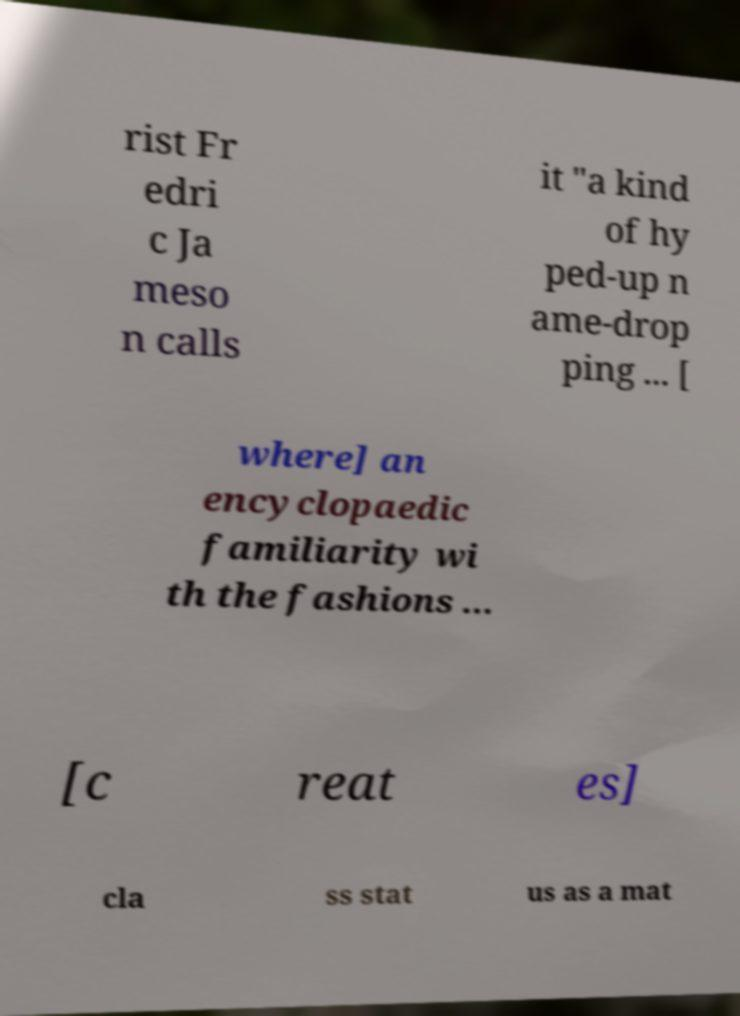Can you accurately transcribe the text from the provided image for me? rist Fr edri c Ja meso n calls it "a kind of hy ped-up n ame-drop ping ... [ where] an encyclopaedic familiarity wi th the fashions ... [c reat es] cla ss stat us as a mat 